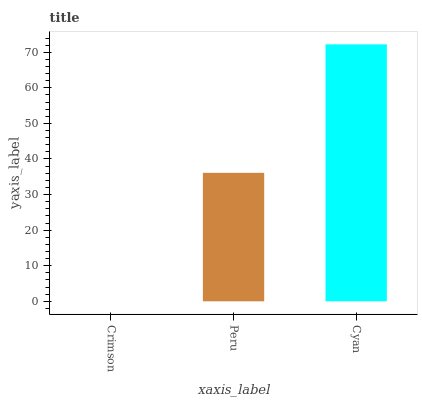Is Crimson the minimum?
Answer yes or no. Yes. Is Cyan the maximum?
Answer yes or no. Yes. Is Peru the minimum?
Answer yes or no. No. Is Peru the maximum?
Answer yes or no. No. Is Peru greater than Crimson?
Answer yes or no. Yes. Is Crimson less than Peru?
Answer yes or no. Yes. Is Crimson greater than Peru?
Answer yes or no. No. Is Peru less than Crimson?
Answer yes or no. No. Is Peru the high median?
Answer yes or no. Yes. Is Peru the low median?
Answer yes or no. Yes. Is Crimson the high median?
Answer yes or no. No. Is Crimson the low median?
Answer yes or no. No. 